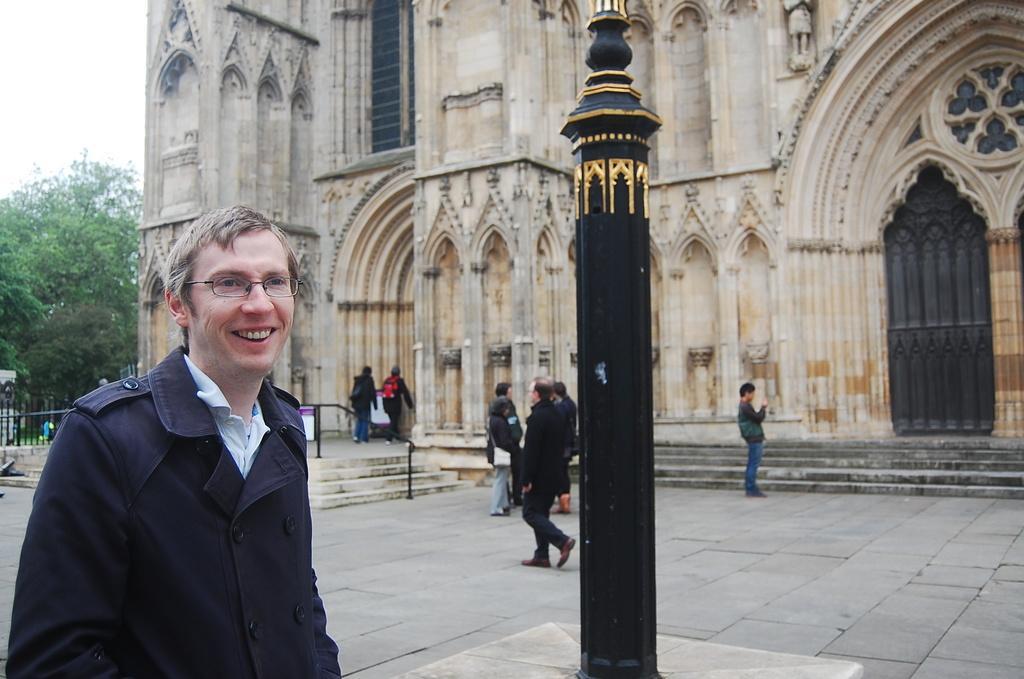Describe this image in one or two sentences. In this image I can see a person. There are few people in the background. I can see a building. In the middle of the image there is a pole. I can see the tree. 